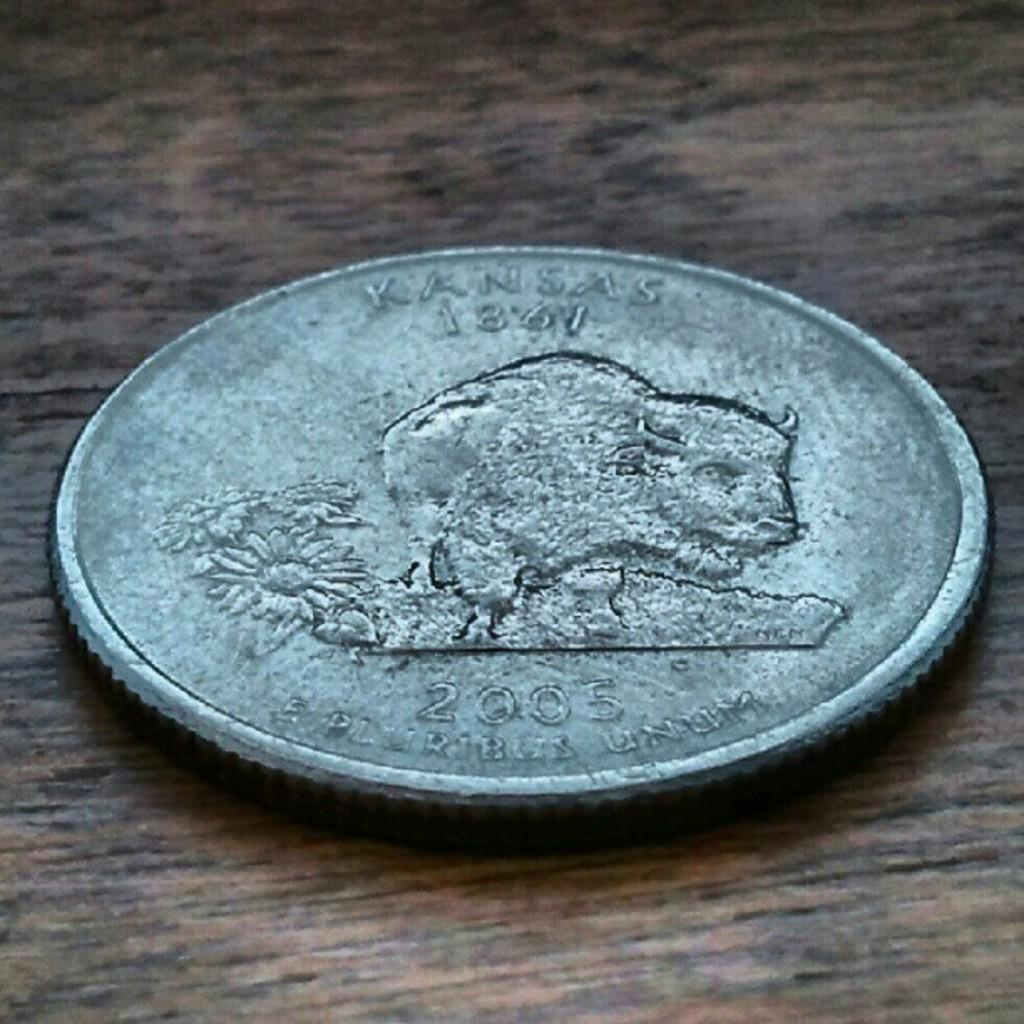<image>
Share a concise interpretation of the image provided. An old looking coin with a buffalo on it and the year 2005 